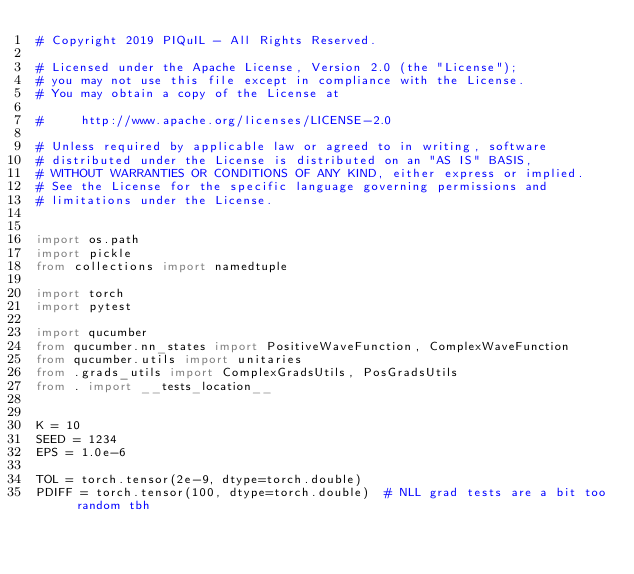Convert code to text. <code><loc_0><loc_0><loc_500><loc_500><_Python_># Copyright 2019 PIQuIL - All Rights Reserved.

# Licensed under the Apache License, Version 2.0 (the "License");
# you may not use this file except in compliance with the License.
# You may obtain a copy of the License at

#     http://www.apache.org/licenses/LICENSE-2.0

# Unless required by applicable law or agreed to in writing, software
# distributed under the License is distributed on an "AS IS" BASIS,
# WITHOUT WARRANTIES OR CONDITIONS OF ANY KIND, either express or implied.
# See the License for the specific language governing permissions and
# limitations under the License.


import os.path
import pickle
from collections import namedtuple

import torch
import pytest

import qucumber
from qucumber.nn_states import PositiveWaveFunction, ComplexWaveFunction
from qucumber.utils import unitaries
from .grads_utils import ComplexGradsUtils, PosGradsUtils
from . import __tests_location__


K = 10
SEED = 1234
EPS = 1.0e-6

TOL = torch.tensor(2e-9, dtype=torch.double)
PDIFF = torch.tensor(100, dtype=torch.double)  # NLL grad tests are a bit too random tbh

</code> 